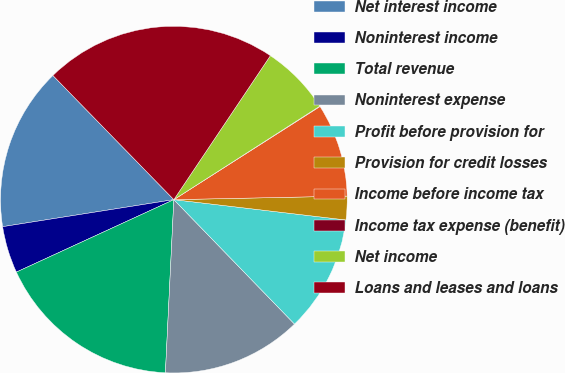Convert chart to OTSL. <chart><loc_0><loc_0><loc_500><loc_500><pie_chart><fcel>Net interest income<fcel>Noninterest income<fcel>Total revenue<fcel>Noninterest expense<fcel>Profit before provision for<fcel>Provision for credit losses<fcel>Income before income tax<fcel>Income tax expense (benefit)<fcel>Net income<fcel>Loans and leases and loans<nl><fcel>15.2%<fcel>4.37%<fcel>17.36%<fcel>13.03%<fcel>10.87%<fcel>2.2%<fcel>8.7%<fcel>0.04%<fcel>6.53%<fcel>21.69%<nl></chart> 